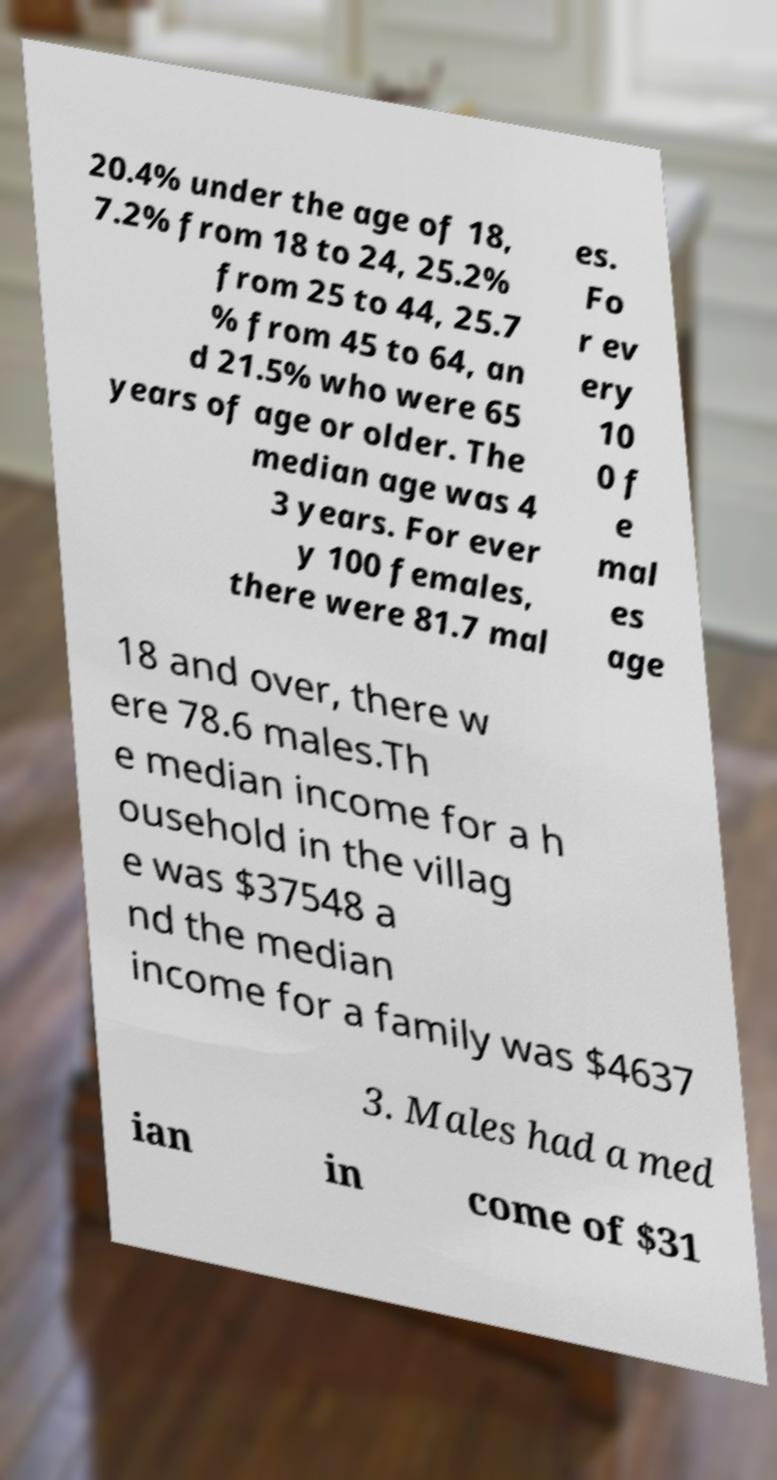Can you accurately transcribe the text from the provided image for me? 20.4% under the age of 18, 7.2% from 18 to 24, 25.2% from 25 to 44, 25.7 % from 45 to 64, an d 21.5% who were 65 years of age or older. The median age was 4 3 years. For ever y 100 females, there were 81.7 mal es. Fo r ev ery 10 0 f e mal es age 18 and over, there w ere 78.6 males.Th e median income for a h ousehold in the villag e was $37548 a nd the median income for a family was $4637 3. Males had a med ian in come of $31 